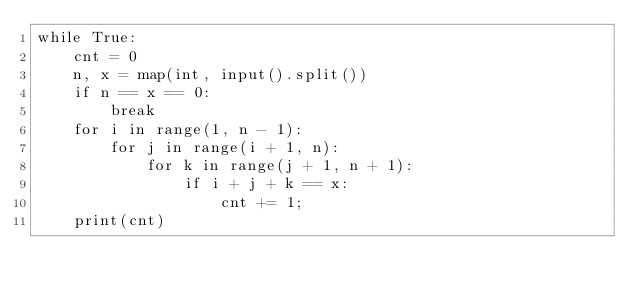<code> <loc_0><loc_0><loc_500><loc_500><_Python_>while True:
    cnt = 0
    n, x = map(int, input().split())
    if n == x == 0:
        break
    for i in range(1, n - 1):
        for j in range(i + 1, n):
            for k in range(j + 1, n + 1):
                if i + j + k == x:
                    cnt += 1;
    print(cnt)</code> 